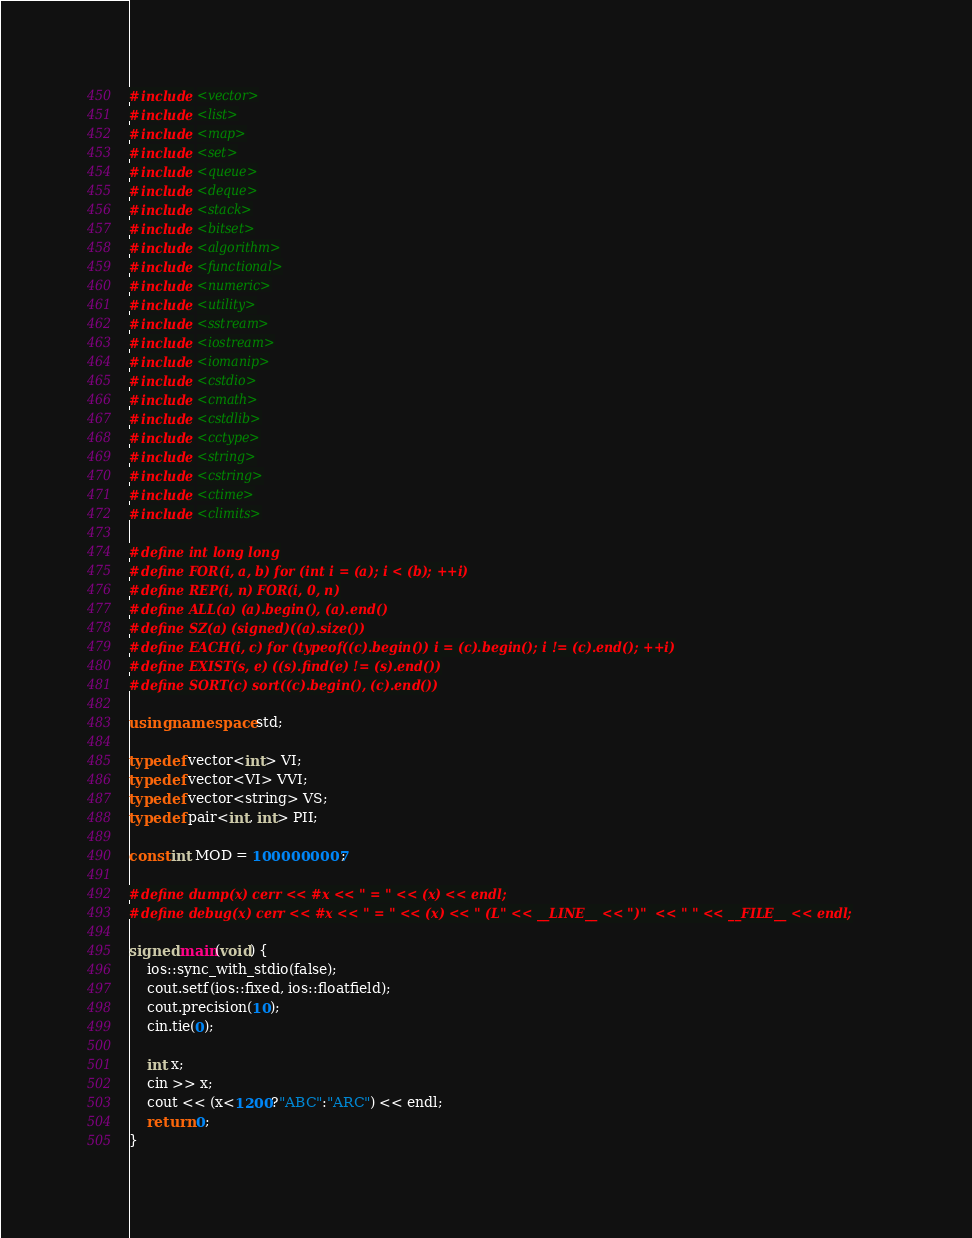Convert code to text. <code><loc_0><loc_0><loc_500><loc_500><_C++_>#include <vector>
#include <list>
#include <map>
#include <set>
#include <queue>
#include <deque>
#include <stack>
#include <bitset>
#include <algorithm>
#include <functional>
#include <numeric>
#include <utility>
#include <sstream>
#include <iostream>
#include <iomanip>
#include <cstdio>
#include <cmath>
#include <cstdlib>
#include <cctype>
#include <string>
#include <cstring>
#include <ctime>
#include <climits>

#define int long long
#define FOR(i, a, b) for (int i = (a); i < (b); ++i)
#define REP(i, n) FOR(i, 0, n)
#define ALL(a) (a).begin(), (a).end()
#define SZ(a) (signed)((a).size())
#define EACH(i, c) for (typeof((c).begin()) i = (c).begin(); i != (c).end(); ++i)
#define EXIST(s, e) ((s).find(e) != (s).end())
#define SORT(c) sort((c).begin(), (c).end())

using namespace std;

typedef vector<int> VI;
typedef vector<VI> VVI;
typedef vector<string> VS;
typedef pair<int, int> PII;

const int MOD = 1000000007;

#define dump(x) cerr << #x << " = " << (x) << endl;
#define debug(x) cerr << #x << " = " << (x) << " (L" << __LINE__ << ")"  << " " << __FILE__ << endl;

signed main(void) {
    ios::sync_with_stdio(false);
    cout.setf(ios::fixed, ios::floatfield);
    cout.precision(10);
    cin.tie(0);

    int x;
    cin >> x;
    cout << (x<1200?"ABC":"ARC") << endl;
    return 0;
}
</code> 